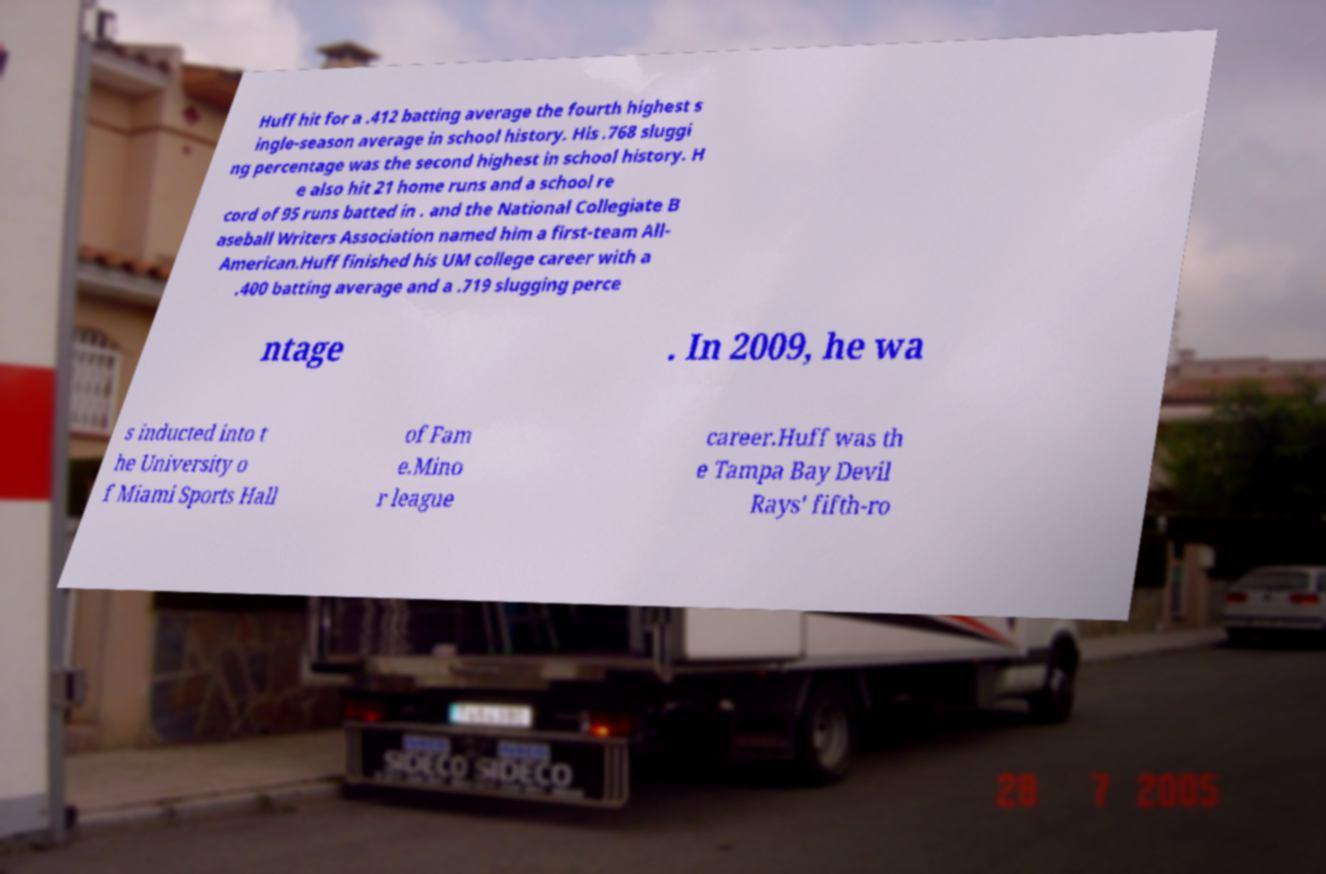Please identify and transcribe the text found in this image. Huff hit for a .412 batting average the fourth highest s ingle-season average in school history. His .768 sluggi ng percentage was the second highest in school history. H e also hit 21 home runs and a school re cord of 95 runs batted in . and the National Collegiate B aseball Writers Association named him a first-team All- American.Huff finished his UM college career with a .400 batting average and a .719 slugging perce ntage . In 2009, he wa s inducted into t he University o f Miami Sports Hall of Fam e.Mino r league career.Huff was th e Tampa Bay Devil Rays' fifth-ro 